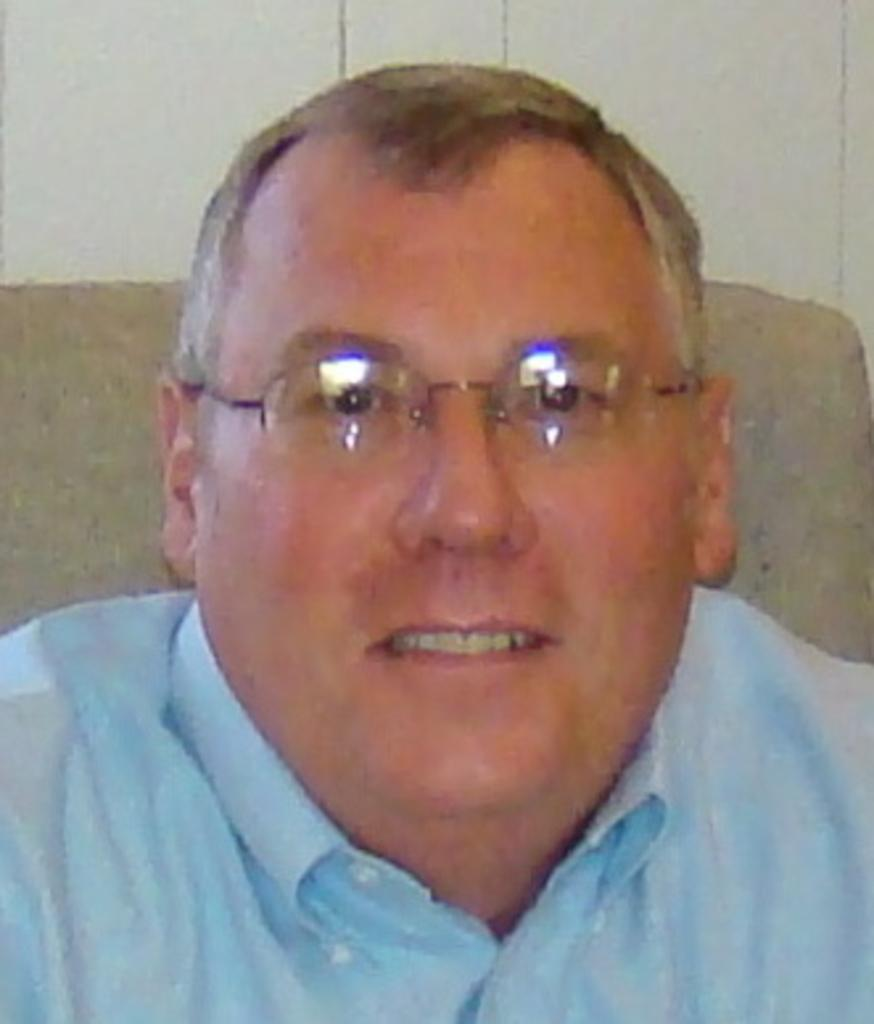Who is present in the image? There is a person in the image. What can be observed about the person's appearance? The person is wearing glasses. What is the person's facial expression? The person is smiling. What can be seen in the background of the image? There is a wall in the background of the image. What type of stitch is the person using to sew in the image? There is no stitch or sewing activity present in the image; the person is simply smiling and wearing glasses. 